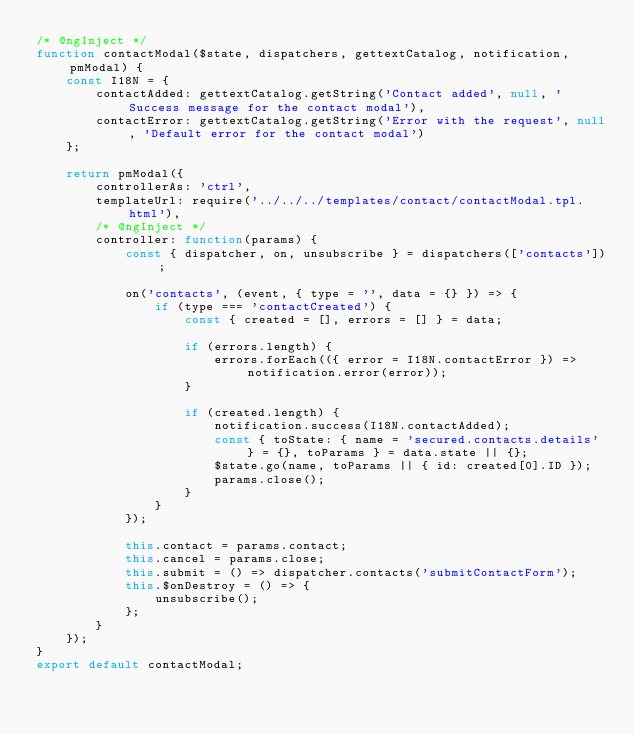Convert code to text. <code><loc_0><loc_0><loc_500><loc_500><_JavaScript_>/* @ngInject */
function contactModal($state, dispatchers, gettextCatalog, notification, pmModal) {
    const I18N = {
        contactAdded: gettextCatalog.getString('Contact added', null, 'Success message for the contact modal'),
        contactError: gettextCatalog.getString('Error with the request', null, 'Default error for the contact modal')
    };

    return pmModal({
        controllerAs: 'ctrl',
        templateUrl: require('../../../templates/contact/contactModal.tpl.html'),
        /* @ngInject */
        controller: function(params) {
            const { dispatcher, on, unsubscribe } = dispatchers(['contacts']);

            on('contacts', (event, { type = '', data = {} }) => {
                if (type === 'contactCreated') {
                    const { created = [], errors = [] } = data;

                    if (errors.length) {
                        errors.forEach(({ error = I18N.contactError }) => notification.error(error));
                    }

                    if (created.length) {
                        notification.success(I18N.contactAdded);
                        const { toState: { name = 'secured.contacts.details' } = {}, toParams } = data.state || {};
                        $state.go(name, toParams || { id: created[0].ID });
                        params.close();
                    }
                }
            });

            this.contact = params.contact;
            this.cancel = params.close;
            this.submit = () => dispatcher.contacts('submitContactForm');
            this.$onDestroy = () => {
                unsubscribe();
            };
        }
    });
}
export default contactModal;
</code> 